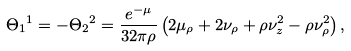Convert formula to latex. <formula><loc_0><loc_0><loc_500><loc_500>\Theta _ { 1 } { ^ { 1 } } = - \Theta _ { 2 } { ^ { 2 } } = \frac { e ^ { - \mu } } { 3 2 \pi \rho } \left ( 2 \mu _ { \rho } + 2 \nu _ { \rho } + \rho \nu _ { z } ^ { 2 } - \rho \nu _ { \rho } ^ { 2 } \right ) ,</formula> 